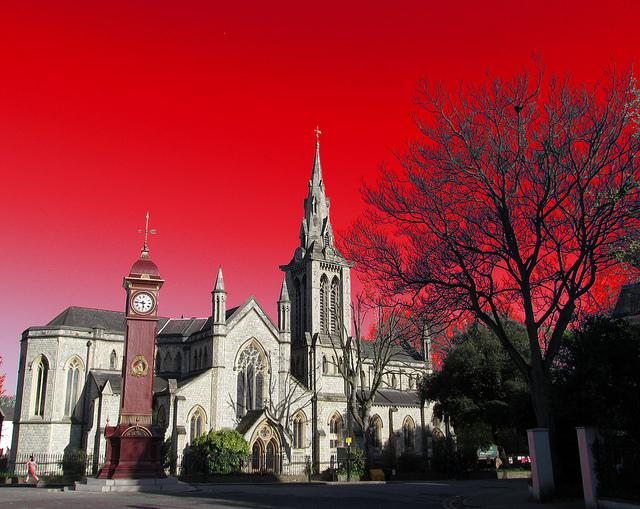What is causing the steeple to glow?
Be succinct. Sunset. Was Photoshop used in this picture?
Short answer required. Yes. What color is the sky?
Write a very short answer. Red. Is this a church?
Concise answer only. Yes. Is there grass in this picture?
Give a very brief answer. No. 